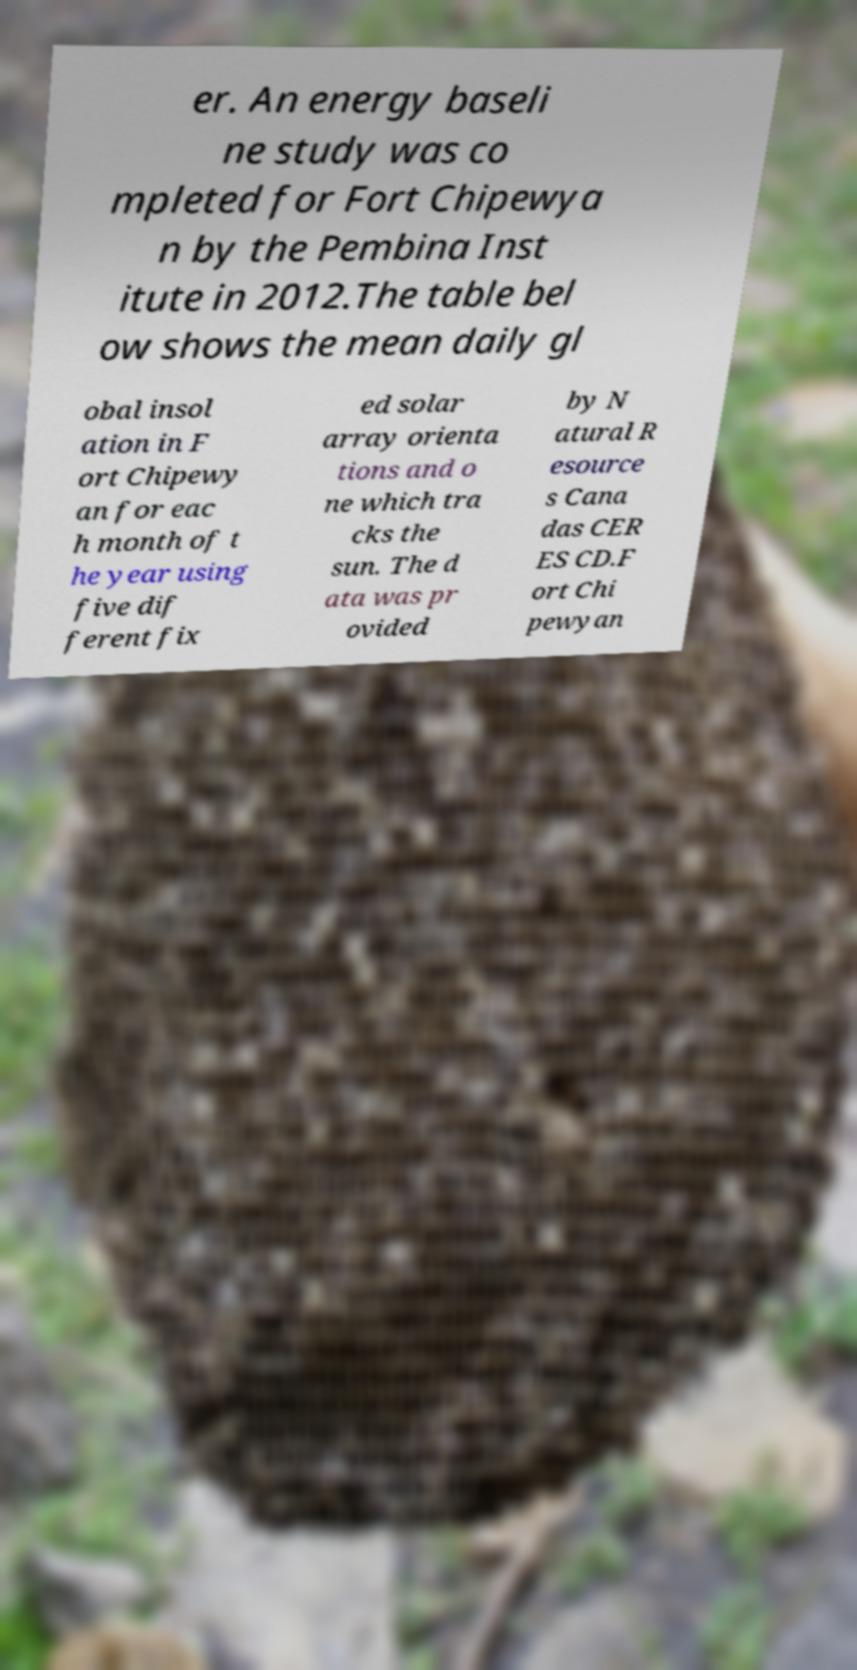Can you read and provide the text displayed in the image?This photo seems to have some interesting text. Can you extract and type it out for me? er. An energy baseli ne study was co mpleted for Fort Chipewya n by the Pembina Inst itute in 2012.The table bel ow shows the mean daily gl obal insol ation in F ort Chipewy an for eac h month of t he year using five dif ferent fix ed solar array orienta tions and o ne which tra cks the sun. The d ata was pr ovided by N atural R esource s Cana das CER ES CD.F ort Chi pewyan 